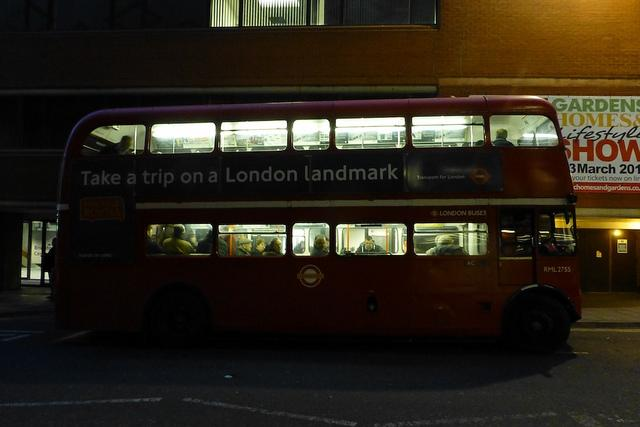Why is the light on inside the double-decker bus? Please explain your reasoning. visibility. The light allows people to see better. 